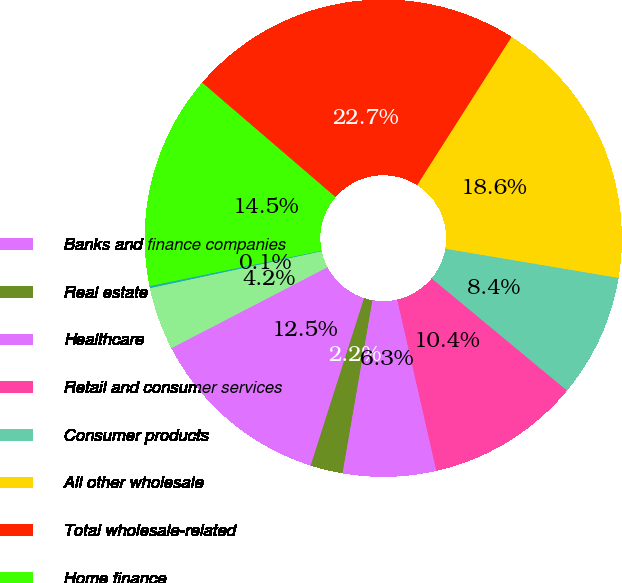Convert chart to OTSL. <chart><loc_0><loc_0><loc_500><loc_500><pie_chart><fcel>Banks and finance companies<fcel>Real estate<fcel>Healthcare<fcel>Retail and consumer services<fcel>Consumer products<fcel>All other wholesale<fcel>Total wholesale-related<fcel>Home finance<fcel>Auto & education finance<fcel>Consumer & small business and<nl><fcel>12.47%<fcel>2.19%<fcel>6.3%<fcel>10.41%<fcel>8.36%<fcel>18.63%<fcel>22.74%<fcel>14.52%<fcel>0.14%<fcel>4.25%<nl></chart> 